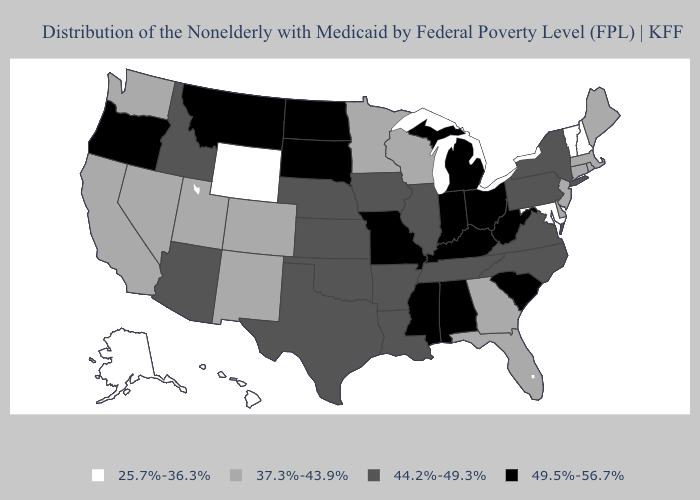What is the value of Kansas?
Short answer required. 44.2%-49.3%. What is the highest value in the USA?
Answer briefly. 49.5%-56.7%. Name the states that have a value in the range 44.2%-49.3%?
Write a very short answer. Arizona, Arkansas, Idaho, Illinois, Iowa, Kansas, Louisiana, Nebraska, New York, North Carolina, Oklahoma, Pennsylvania, Tennessee, Texas, Virginia. Among the states that border Oklahoma , which have the highest value?
Short answer required. Missouri. What is the value of Maryland?
Give a very brief answer. 25.7%-36.3%. Which states have the lowest value in the South?
Give a very brief answer. Maryland. Does Hawaii have the lowest value in the West?
Give a very brief answer. Yes. Does the first symbol in the legend represent the smallest category?
Answer briefly. Yes. Does the first symbol in the legend represent the smallest category?
Short answer required. Yes. What is the value of California?
Give a very brief answer. 37.3%-43.9%. Name the states that have a value in the range 25.7%-36.3%?
Be succinct. Alaska, Hawaii, Maryland, New Hampshire, Vermont, Wyoming. Does the first symbol in the legend represent the smallest category?
Be succinct. Yes. Does Montana have the highest value in the West?
Answer briefly. Yes. Name the states that have a value in the range 25.7%-36.3%?
Be succinct. Alaska, Hawaii, Maryland, New Hampshire, Vermont, Wyoming. 